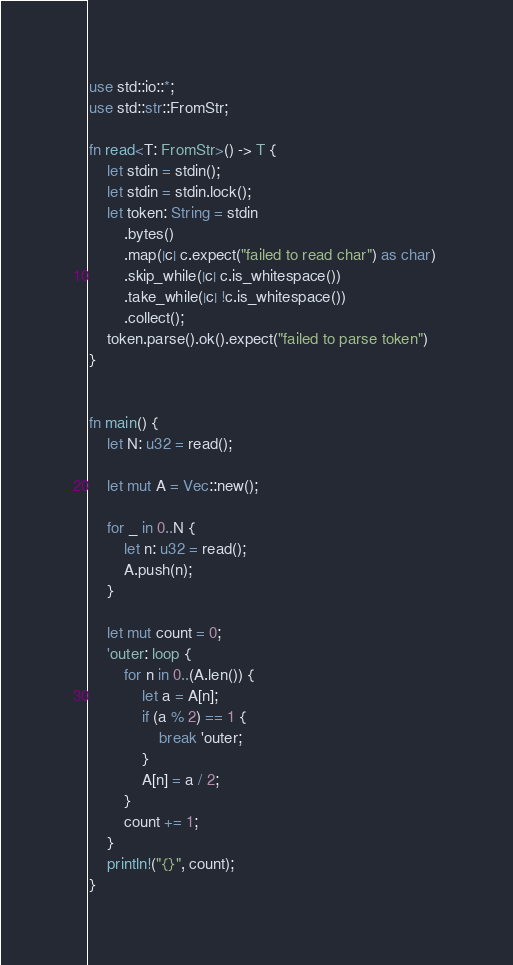<code> <loc_0><loc_0><loc_500><loc_500><_Rust_>use std::io::*;
use std::str::FromStr;

fn read<T: FromStr>() -> T {
    let stdin = stdin();
    let stdin = stdin.lock();
    let token: String = stdin
        .bytes()
        .map(|c| c.expect("failed to read char") as char) 
        .skip_while(|c| c.is_whitespace())
        .take_while(|c| !c.is_whitespace())
        .collect();
    token.parse().ok().expect("failed to parse token")
}


fn main() {
    let N: u32 = read();

    let mut A = Vec::new();

    for _ in 0..N {
        let n: u32 = read();
        A.push(n);
    }

    let mut count = 0;
    'outer: loop {
        for n in 0..(A.len()) {
            let a = A[n];
            if (a % 2) == 1 {
                break 'outer;
            }
            A[n] = a / 2;
        }
        count += 1;
    }
    println!("{}", count);
}
</code> 